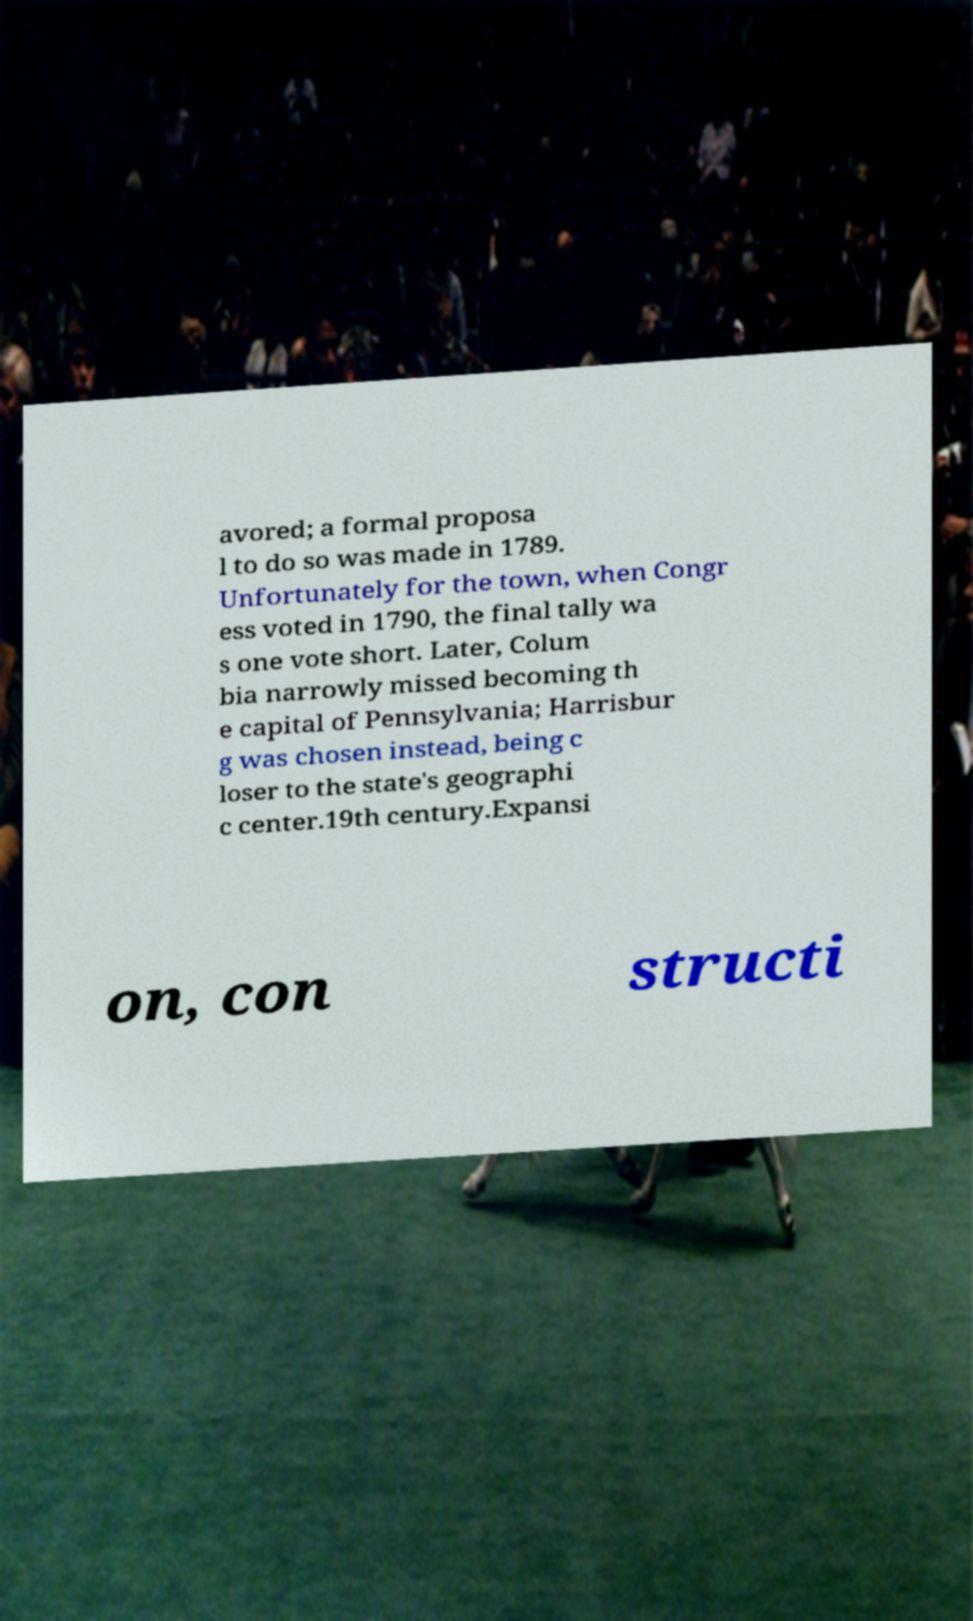For documentation purposes, I need the text within this image transcribed. Could you provide that? avored; a formal proposa l to do so was made in 1789. Unfortunately for the town, when Congr ess voted in 1790, the final tally wa s one vote short. Later, Colum bia narrowly missed becoming th e capital of Pennsylvania; Harrisbur g was chosen instead, being c loser to the state's geographi c center.19th century.Expansi on, con structi 